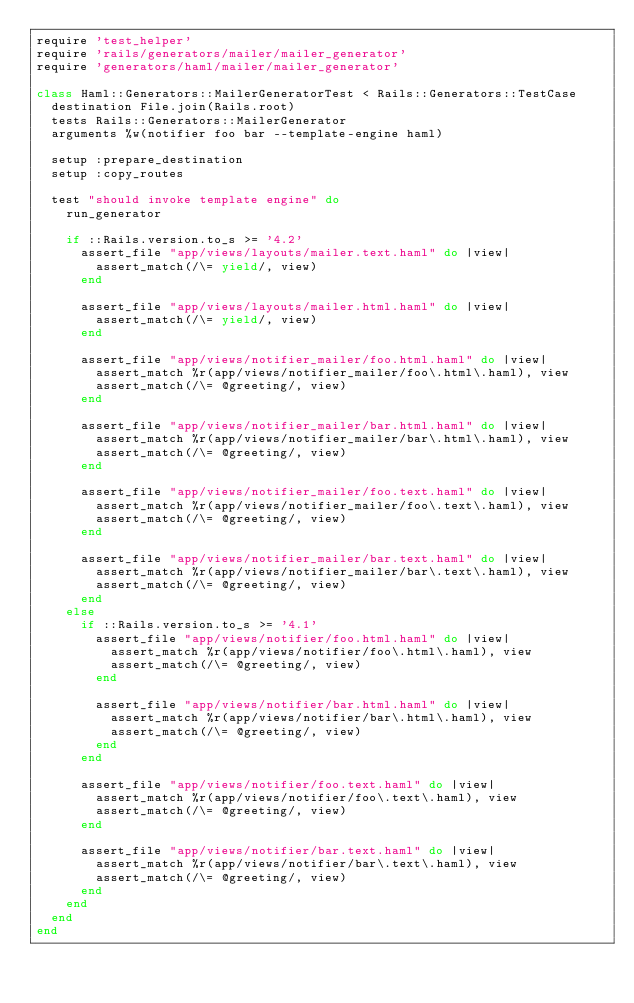Convert code to text. <code><loc_0><loc_0><loc_500><loc_500><_Ruby_>require 'test_helper'
require 'rails/generators/mailer/mailer_generator'
require 'generators/haml/mailer/mailer_generator'

class Haml::Generators::MailerGeneratorTest < Rails::Generators::TestCase
  destination File.join(Rails.root)
  tests Rails::Generators::MailerGenerator
  arguments %w(notifier foo bar --template-engine haml)

  setup :prepare_destination
  setup :copy_routes

  test "should invoke template engine" do
    run_generator

    if ::Rails.version.to_s >= '4.2'
      assert_file "app/views/layouts/mailer.text.haml" do |view|
        assert_match(/\= yield/, view)
      end

      assert_file "app/views/layouts/mailer.html.haml" do |view|
        assert_match(/\= yield/, view)
      end

      assert_file "app/views/notifier_mailer/foo.html.haml" do |view|
        assert_match %r(app/views/notifier_mailer/foo\.html\.haml), view
        assert_match(/\= @greeting/, view)
      end

      assert_file "app/views/notifier_mailer/bar.html.haml" do |view|
        assert_match %r(app/views/notifier_mailer/bar\.html\.haml), view
        assert_match(/\= @greeting/, view)
      end

      assert_file "app/views/notifier_mailer/foo.text.haml" do |view|
        assert_match %r(app/views/notifier_mailer/foo\.text\.haml), view
        assert_match(/\= @greeting/, view)
      end

      assert_file "app/views/notifier_mailer/bar.text.haml" do |view|
        assert_match %r(app/views/notifier_mailer/bar\.text\.haml), view
        assert_match(/\= @greeting/, view)
      end
    else
      if ::Rails.version.to_s >= '4.1'
        assert_file "app/views/notifier/foo.html.haml" do |view|
          assert_match %r(app/views/notifier/foo\.html\.haml), view
          assert_match(/\= @greeting/, view)
        end

        assert_file "app/views/notifier/bar.html.haml" do |view|
          assert_match %r(app/views/notifier/bar\.html\.haml), view
          assert_match(/\= @greeting/, view)
        end
      end

      assert_file "app/views/notifier/foo.text.haml" do |view|
        assert_match %r(app/views/notifier/foo\.text\.haml), view
        assert_match(/\= @greeting/, view)
      end

      assert_file "app/views/notifier/bar.text.haml" do |view|
        assert_match %r(app/views/notifier/bar\.text\.haml), view
        assert_match(/\= @greeting/, view)
      end
    end
  end
end
</code> 